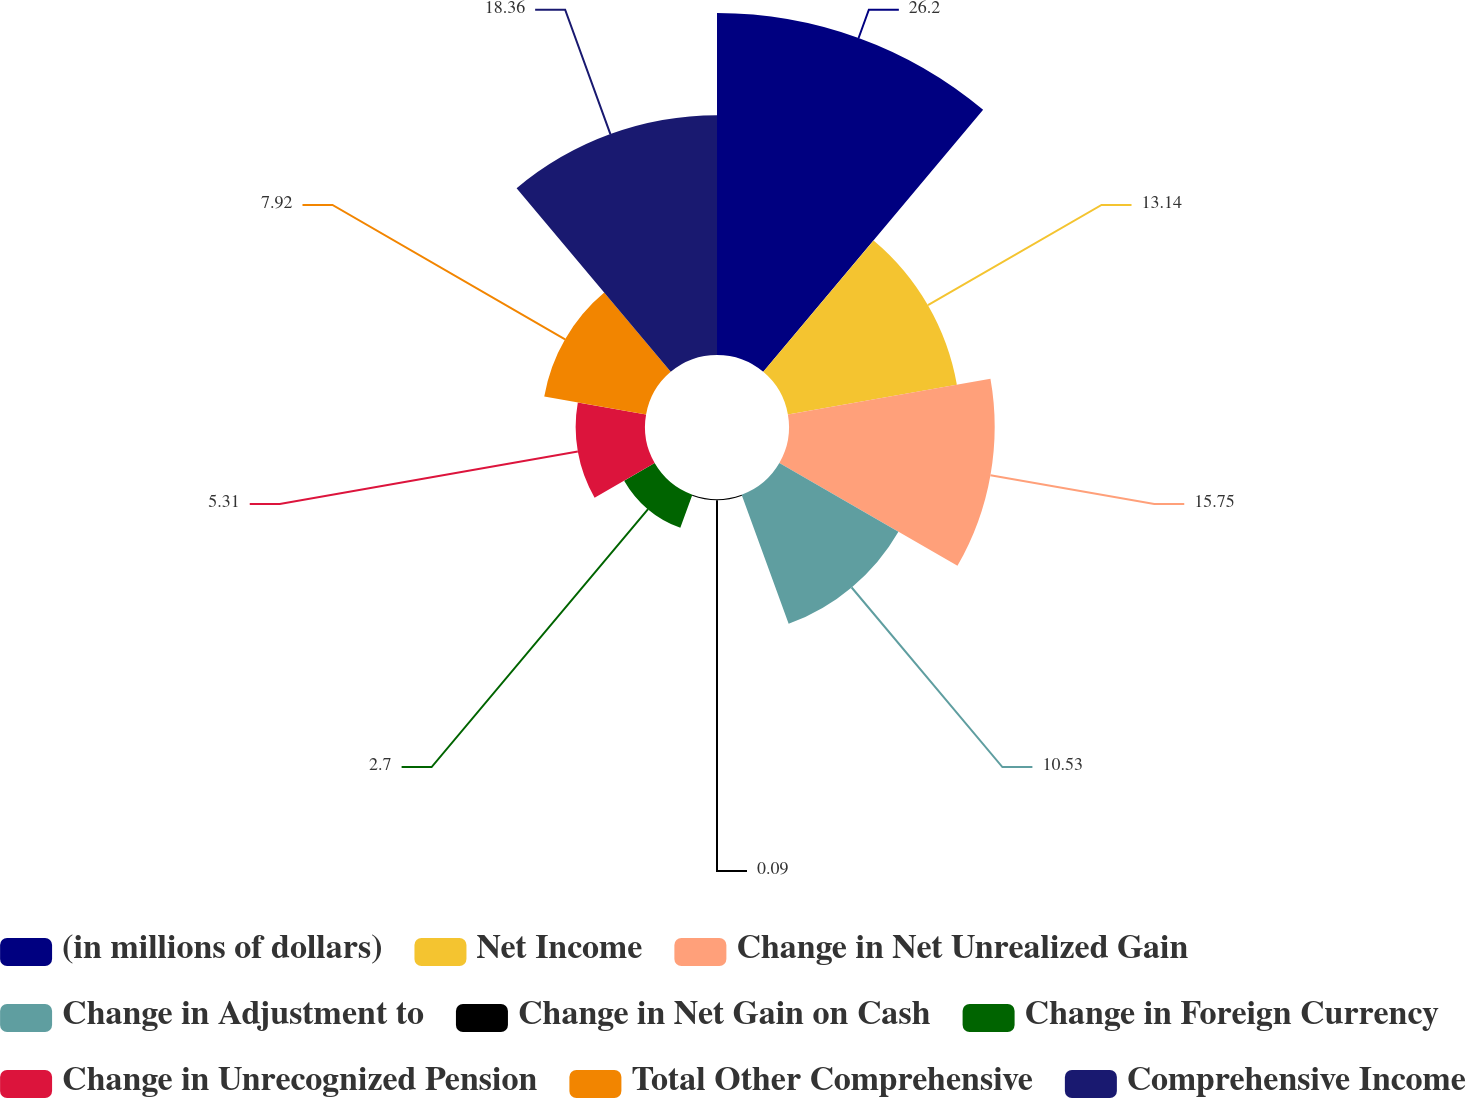Convert chart. <chart><loc_0><loc_0><loc_500><loc_500><pie_chart><fcel>(in millions of dollars)<fcel>Net Income<fcel>Change in Net Unrealized Gain<fcel>Change in Adjustment to<fcel>Change in Net Gain on Cash<fcel>Change in Foreign Currency<fcel>Change in Unrecognized Pension<fcel>Total Other Comprehensive<fcel>Comprehensive Income<nl><fcel>26.19%<fcel>13.14%<fcel>15.75%<fcel>10.53%<fcel>0.09%<fcel>2.7%<fcel>5.31%<fcel>7.92%<fcel>18.36%<nl></chart> 